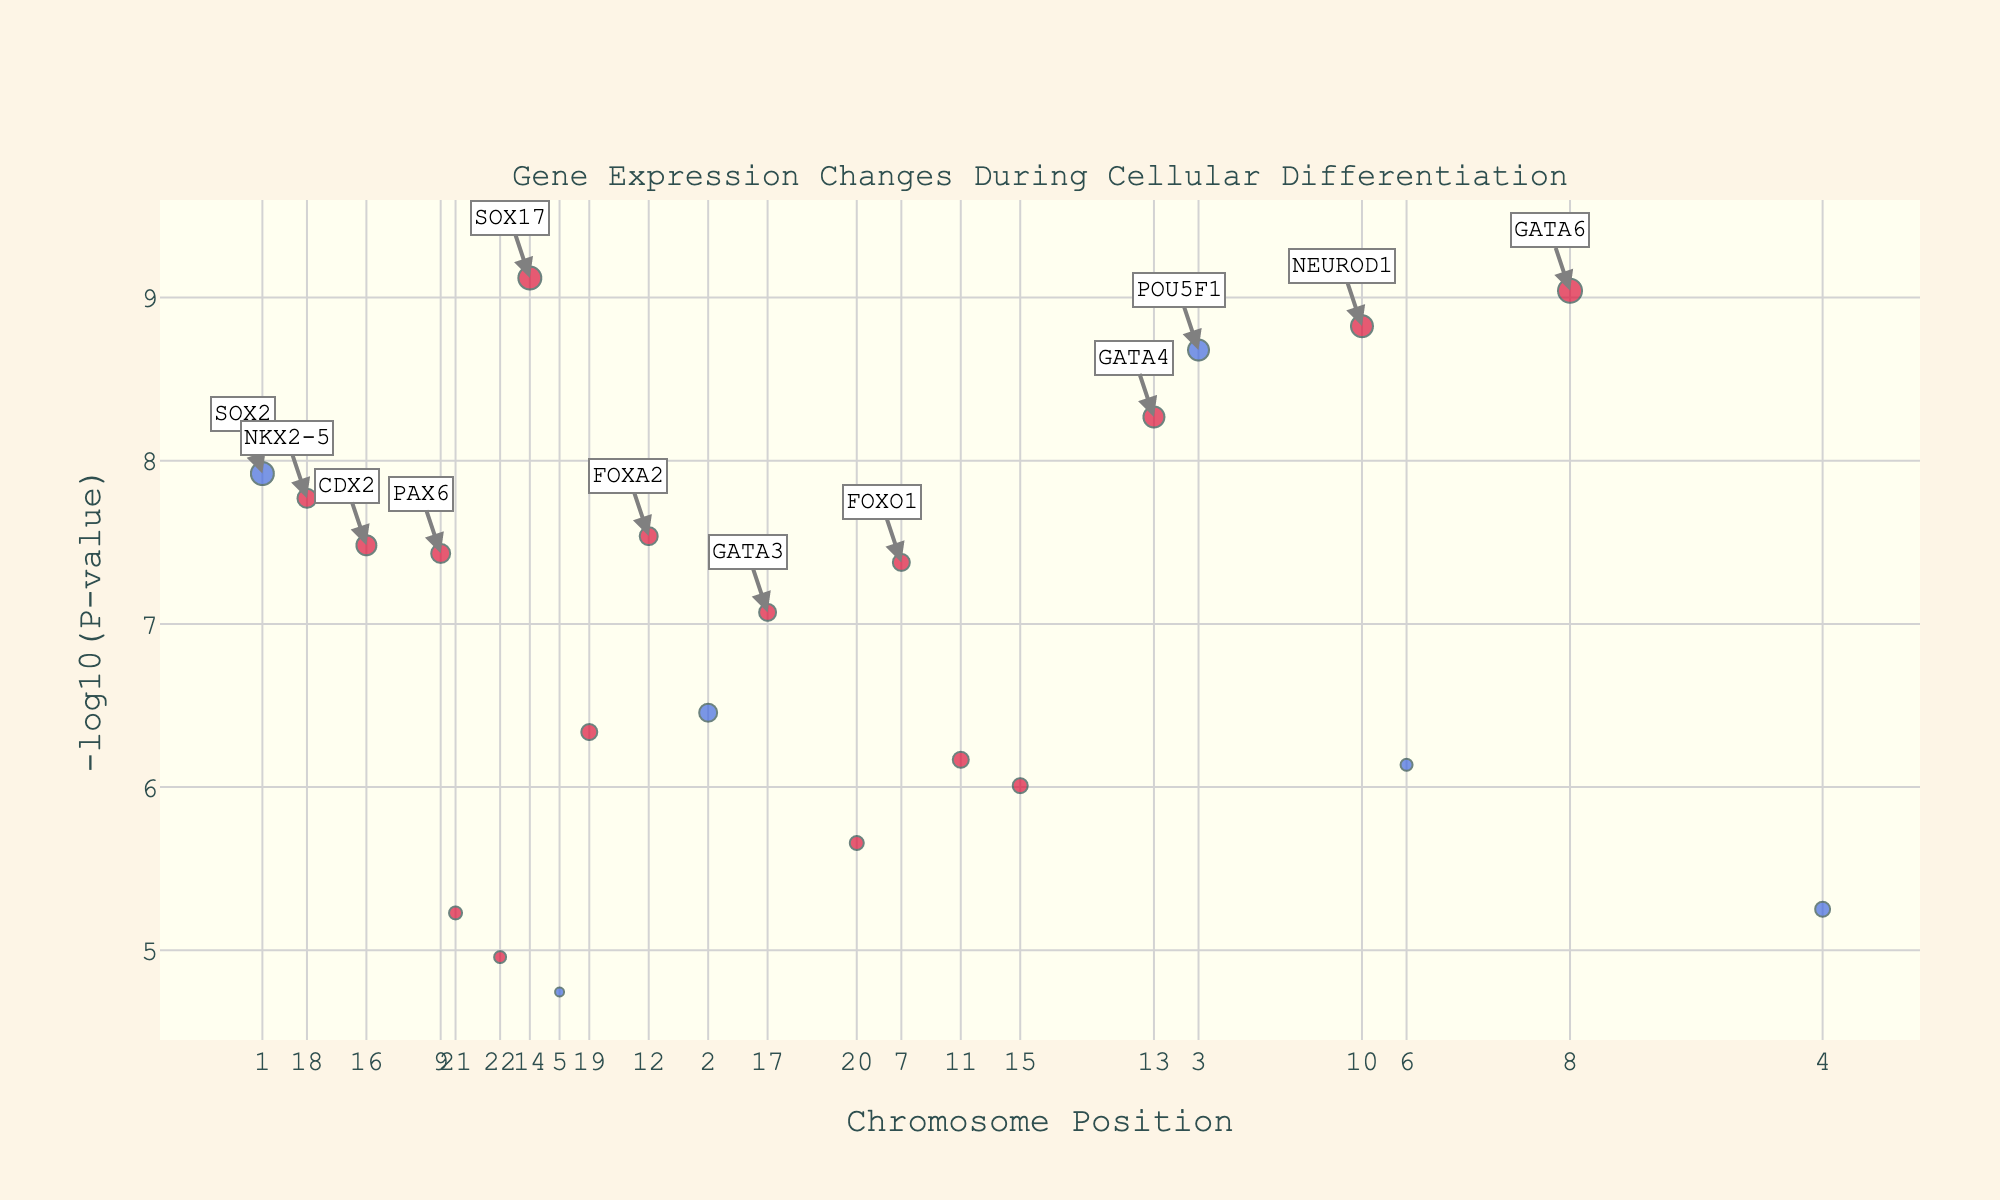What's the main title of the plot? The plot title is usually displayed at the top of the figure. In this case, the plot title provided in the code is "Gene Expression Changes During Cellular Differentiation".
Answer: Gene Expression Changes During Cellular Differentiation What is the x-axis label? The label for the x-axis is usually found along the horizontal axis of the plot. According to the code, the x-axis label is "Chromosome Position".
Answer: Chromosome Position What colors are used to represent the data points in the plot? The colors represent different gene changes; genes with positive log fold changes are marked in crimson, and those with negative log fold changes are marked in royal blue.
Answer: Crimson and royal blue How many genes have a log fold change greater than 2? To find the genes with a log fold change greater than 2, look for the genes marked in crimson with larger markers, indicating significant changes. By examining the data, you will find 4 such genes: GATA6, NEUROD1, GATA4, and SOX17.
Answer: 4 Which gene has the highest -log10(P-value) and what is its value? To determine this, look for the data point furthest up on the y-axis, as -log10(P-value) increases with height. The gene with the highest value is GATA6 at approximately 9.038.
Answer: GATA6 at ~9.038 Compare the significance levels of SOX2 and FOXO1. Which one is more significant, and by how much? Compare their -log10(P-values), where a higher value indicates greater significance. SOX2 has a -log10(P-value) of ~7.921, and FOXO1 has ~7.377. The difference is ~0.544.
Answer: SOX2 is more significant by ~0.544 How many genes have a negative log fold change? Look for the genes marked in royal blue, as these indicate negative log fold changes. By examining the plot and data, 6 genes fall into this category: SOX2, NANOG, POU5F1, KLF4, MYC, and ESRRB.
Answer: 6 Which genes are specifically annotated in the plot? The codes specify that only genes with -log10(P-value) greater than 7 will be annotated. By cross-referencing these with the data, we identify the annotated genes: SOX2, POU5F1, FOXO1, GATA6, NEUROD1, GATA4, and SOX17.
Answer: SOX2, POU5F1, FOXO1, GATA6, NEUROD1, GATA4, SOX17 What's the total number of genes plotted in the figure? Count all of the unique gene symbols listed in the data set to determine how many are represented in the plot. There are 22 genes in total.
Answer: 22 